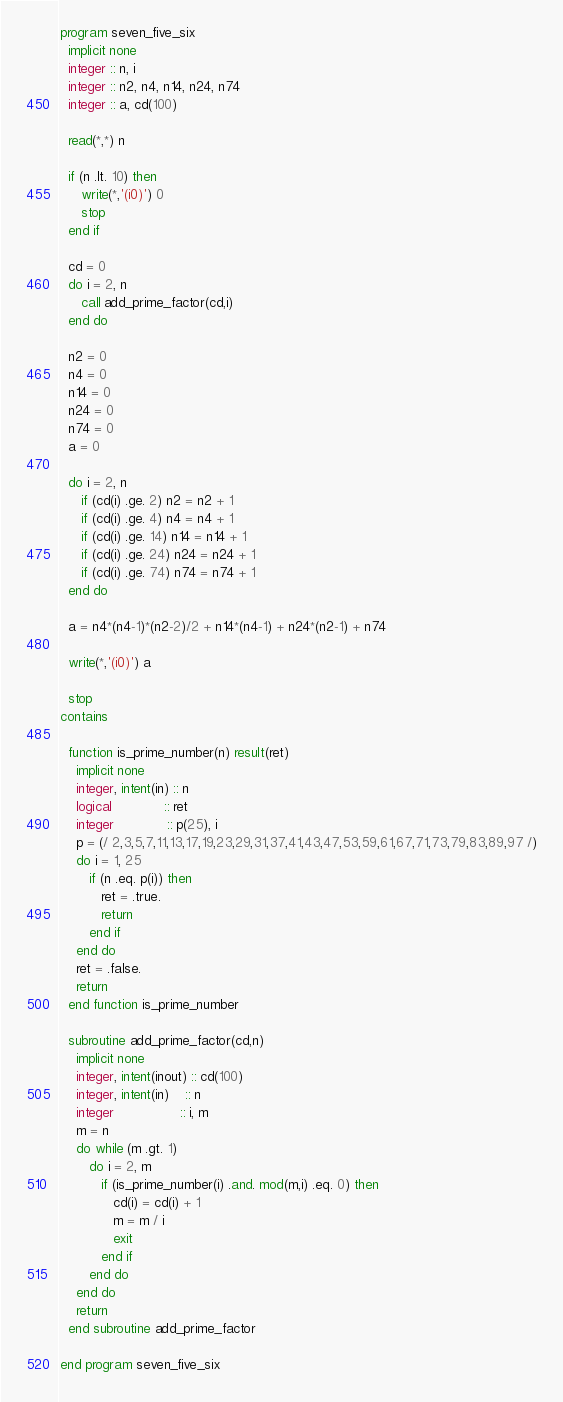<code> <loc_0><loc_0><loc_500><loc_500><_FORTRAN_>program seven_five_six
  implicit none
  integer :: n, i
  integer :: n2, n4, n14, n24, n74
  integer :: a, cd(100)
  
  read(*,*) n
  
  if (n .lt. 10) then
     write(*,'(i0)') 0
     stop
  end if
  
  cd = 0
  do i = 2, n
     call add_prime_factor(cd,i)
  end do

  n2 = 0
  n4 = 0
  n14 = 0
  n24 = 0
  n74 = 0
  a = 0
  
  do i = 2, n
     if (cd(i) .ge. 2) n2 = n2 + 1
     if (cd(i) .ge. 4) n4 = n4 + 1
     if (cd(i) .ge. 14) n14 = n14 + 1
     if (cd(i) .ge. 24) n24 = n24 + 1
     if (cd(i) .ge. 74) n74 = n74 + 1
  end do
  
  a = n4*(n4-1)*(n2-2)/2 + n14*(n4-1) + n24*(n2-1) + n74
  
  write(*,'(i0)') a
  
  stop
contains

  function is_prime_number(n) result(ret)
    implicit none
    integer, intent(in) :: n
    logical             :: ret
    integer             :: p(25), i
    p = (/ 2,3,5,7,11,13,17,19,23,29,31,37,41,43,47,53,59,61,67,71,73,79,83,89,97 /)
    do i = 1, 25
       if (n .eq. p(i)) then
          ret = .true.
          return
       end if
    end do
    ret = .false.
    return
  end function is_prime_number

  subroutine add_prime_factor(cd,n)
    implicit none
    integer, intent(inout) :: cd(100)
    integer, intent(in)    :: n
    integer                :: i, m
    m = n
    do while (m .gt. 1)
       do i = 2, m
          if (is_prime_number(i) .and. mod(m,i) .eq. 0) then
             cd(i) = cd(i) + 1
             m = m / i
             exit
          end if
       end do
    end do
    return
  end subroutine add_prime_factor
  
end program seven_five_six</code> 